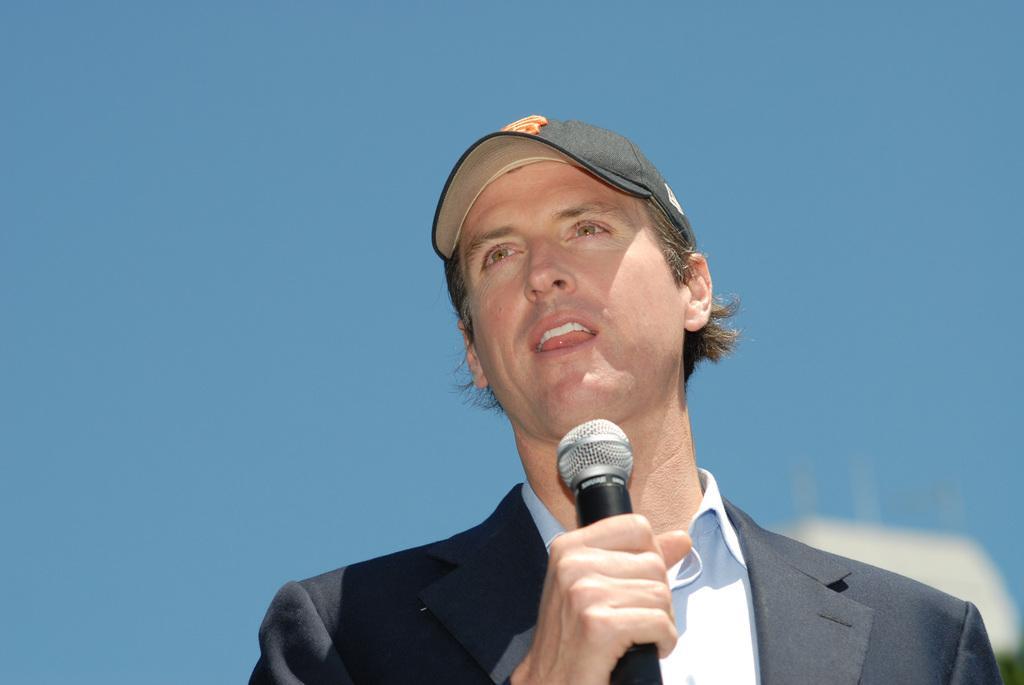How would you summarize this image in a sentence or two? In this image there is a person holding microphone and he is talking. At the top there is a sky. He is wearing black suit and black cap. 